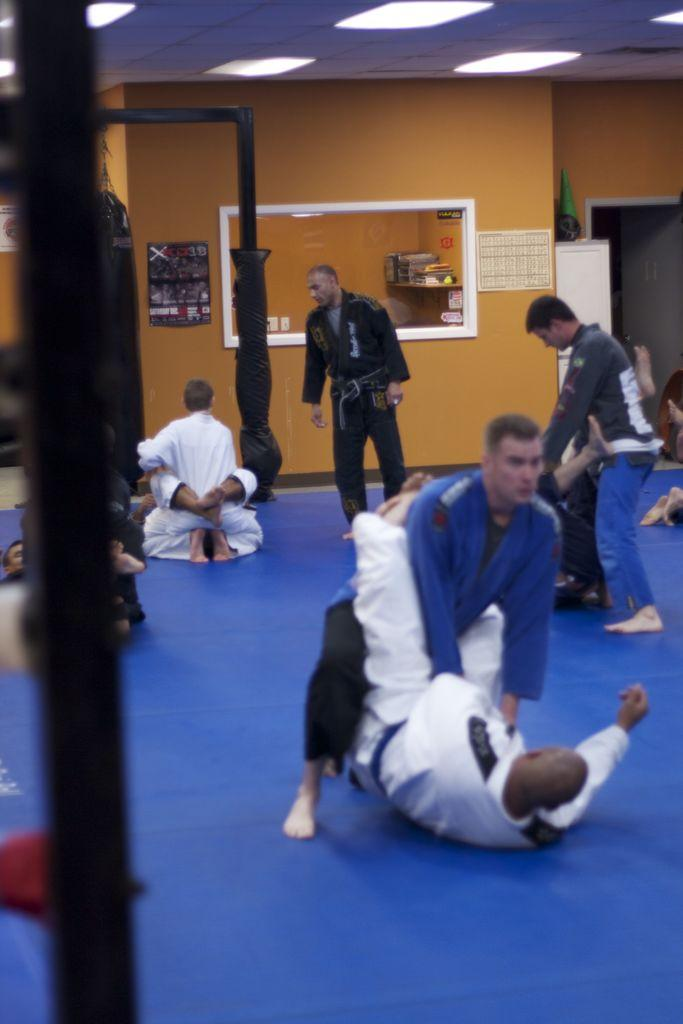What is the man in the image doing? There is a man standing in the image, but we cannot determine his actions from the provided facts. What are the people on the floor doing in the image? The group of people on the floor in the image is not described in terms of their actions or activities. What are the rods used for in the image? The purpose or function of the rods in the image is not mentioned in the provided facts. What do the posters depict or advertise in the image? The content or message of the posters in the image is not specified in the provided facts. What type of lights are present in the image? The type or style of lights in the image is not described in the provided facts. What are the walls made of in the image? The material or construction of the walls in the image is not mentioned in the provided facts. What objects can be seen in the image? The provided facts mention that there are some objects in the image, but they do not specify what these objects are. Can you tell me how many kittens are playing with the stranger in the image? There is no mention of a stranger or kittens in the provided facts, so this question cannot be answered. 